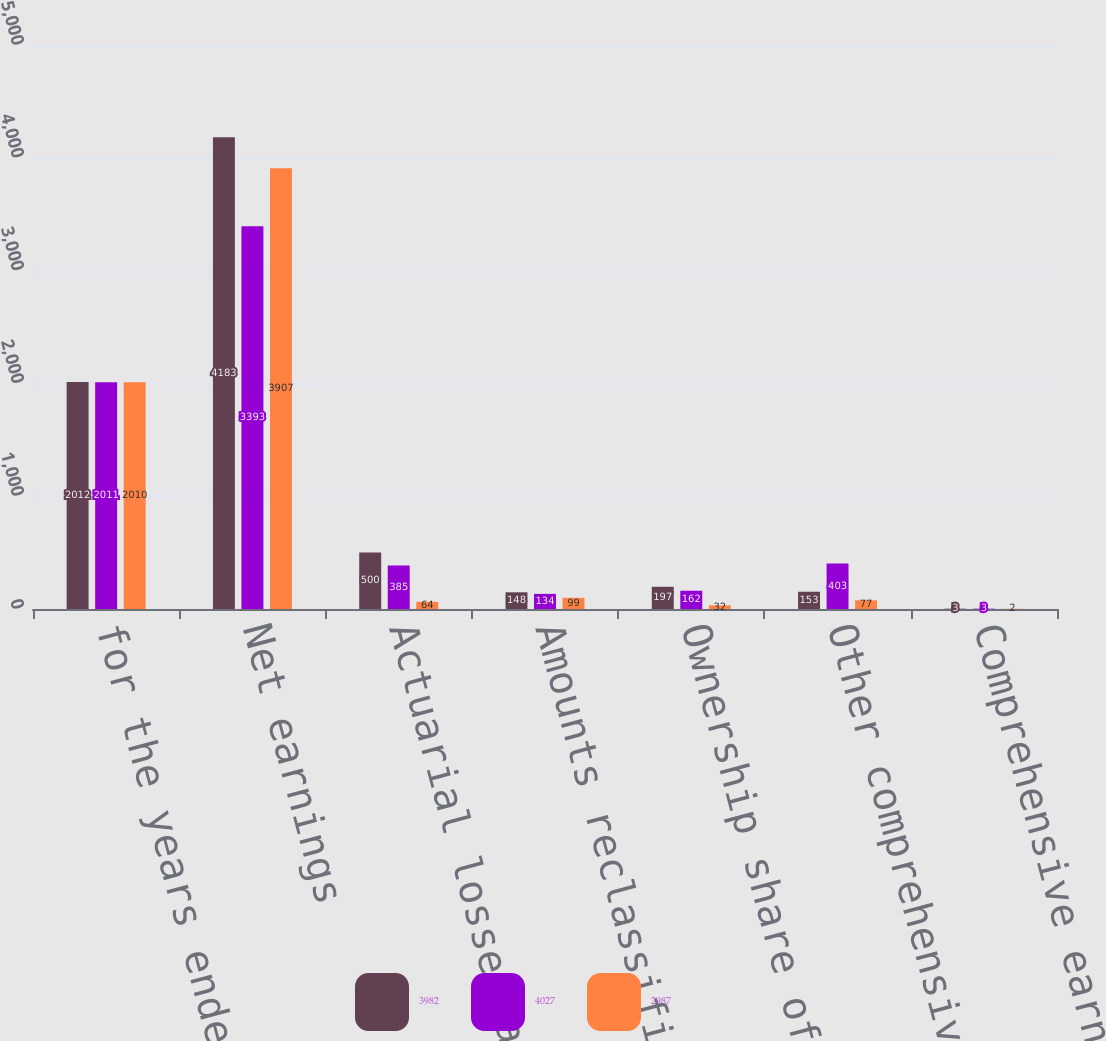Convert chart to OTSL. <chart><loc_0><loc_0><loc_500><loc_500><stacked_bar_chart><ecel><fcel>for the years ended December<fcel>Net earnings<fcel>Actuarial losses and prior<fcel>Amounts reclassified to net<fcel>Ownership share of SABMiller's<fcel>Other comprehensive (losses)<fcel>Comprehensive earnings<nl><fcel>3982<fcel>2012<fcel>4183<fcel>500<fcel>148<fcel>197<fcel>153<fcel>3<nl><fcel>4027<fcel>2011<fcel>3393<fcel>385<fcel>134<fcel>162<fcel>403<fcel>3<nl><fcel>2987<fcel>2010<fcel>3907<fcel>64<fcel>99<fcel>32<fcel>77<fcel>2<nl></chart> 